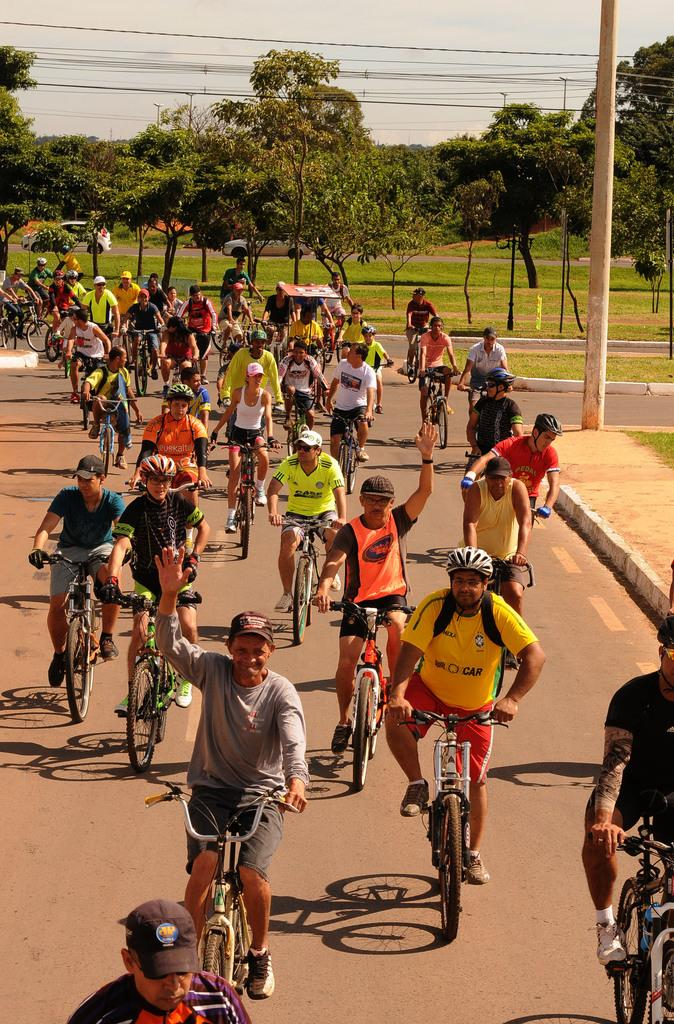What are the majority of people in the image doing? Most of the persons in the image are riding bicycles. What safety precaution are the bicycle riders taking? The persons riding bicycles are wearing helmets. What can be seen in the background of the image? There are trees and grass in the background of the image. What objects are present in the image besides the bicycles and people? There is a pole and cables in the image. What scent can be detected in the image? There is no information about a scent in the image, so it cannot be determined. How do the bicycle riders turn during the rainstorm in the image? There is no rainstorm present in the image, and therefore no need for the bicycle riders to turn during a rainstorm. 